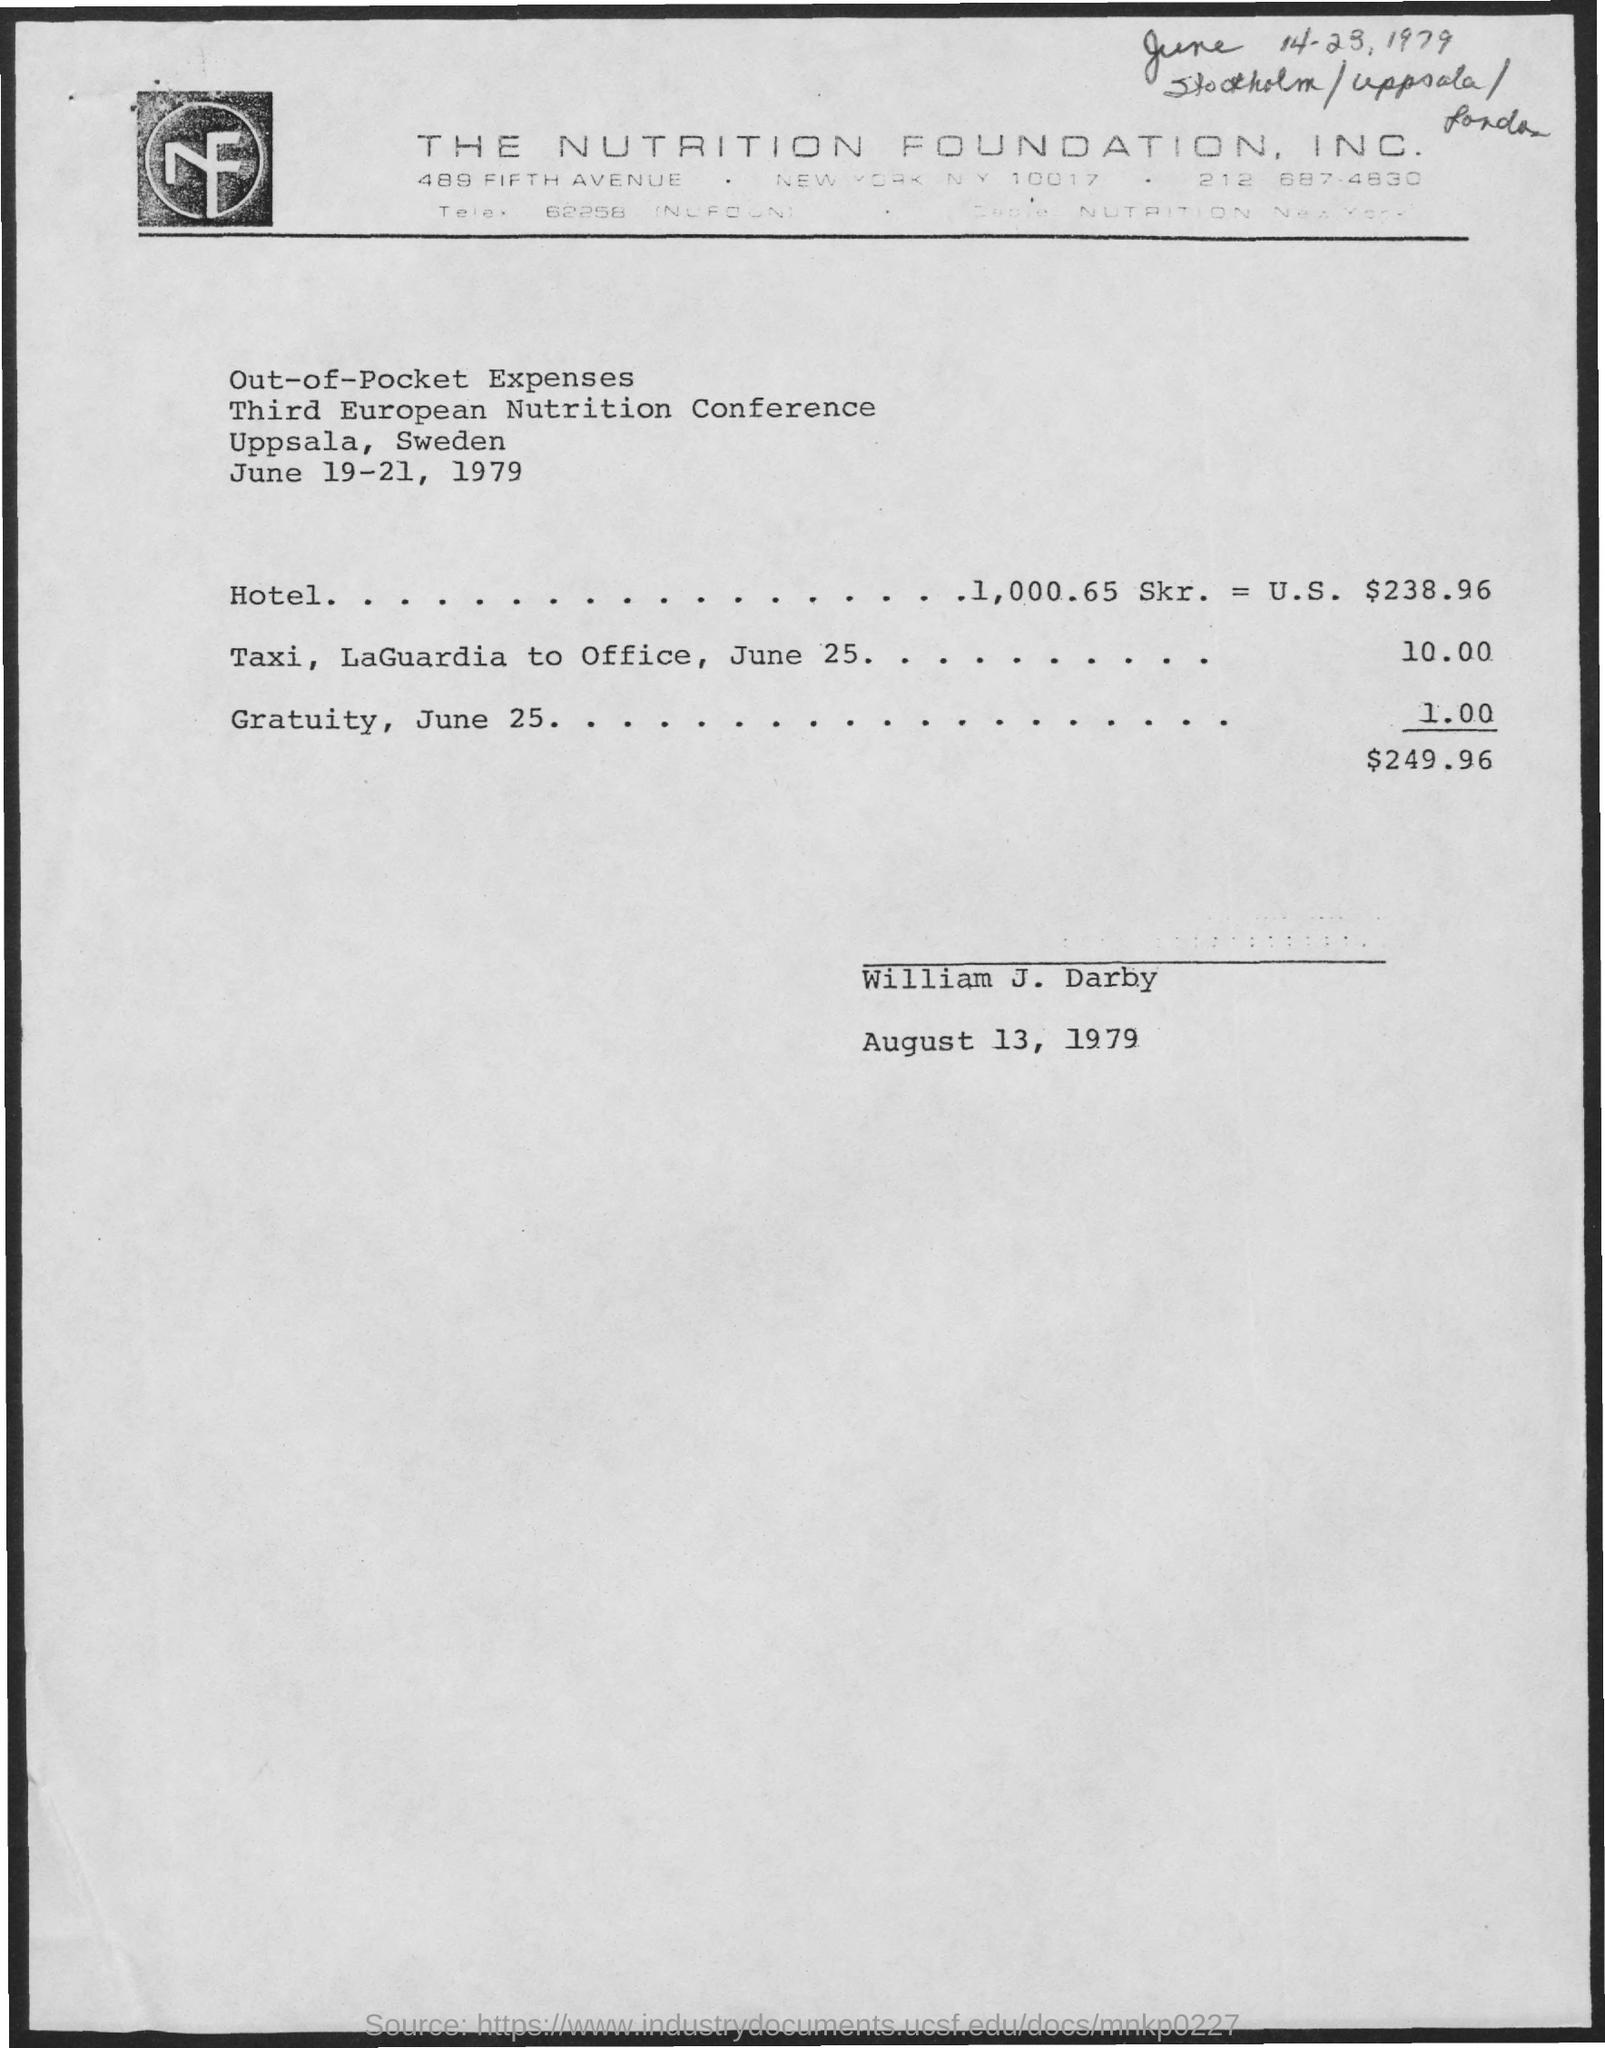Point out several critical features in this image. The conference is taking place in Uppsala, Sweden. The conference is scheduled for June 19-21, 1979. 